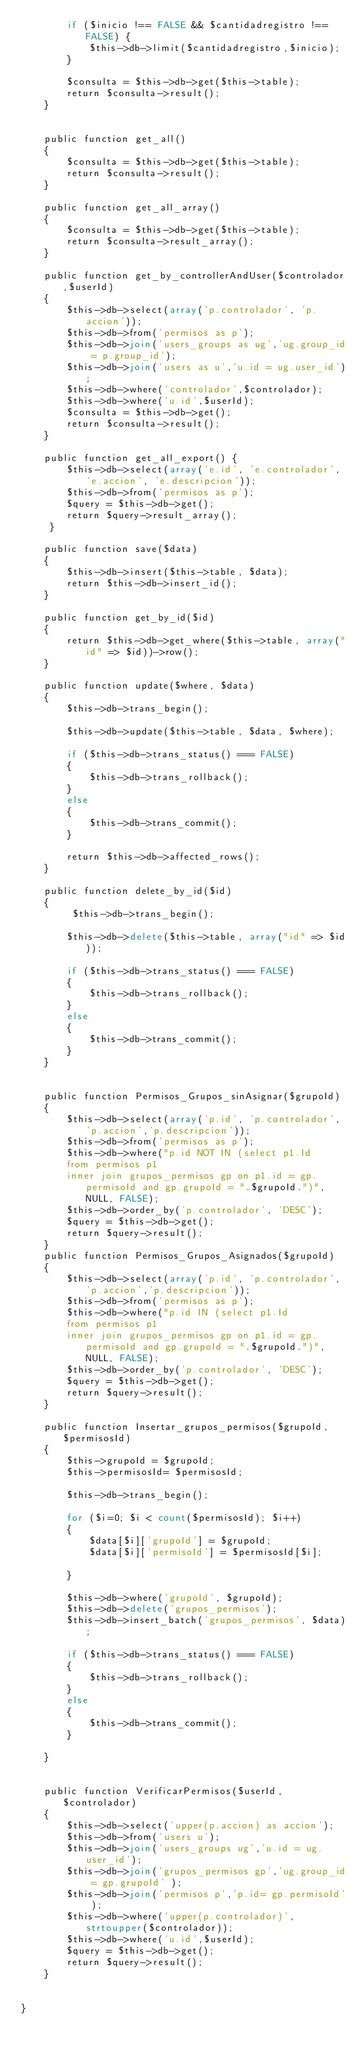Convert code to text. <code><loc_0><loc_0><loc_500><loc_500><_PHP_>		if ($inicio !== FALSE && $cantidadregistro !== FALSE) {
			$this->db->limit($cantidadregistro,$inicio);
		}

		$consulta = $this->db->get($this->table);
		return $consulta->result();
	}


	public function get_all()
	{
		$consulta = $this->db->get($this->table);
		return $consulta->result();
	}

	public function get_all_array()
	{			
		$consulta = $this->db->get($this->table);
		return $consulta->result_array();
	}

	public function get_by_controllerAndUser($controlador,$userId)
	{
		$this->db->select(array('p.controlador', 'p.accion'));
		$this->db->from('permisos as p');
		$this->db->join('users_groups as ug','ug.group_id = p.group_id');
		$this->db->join('users as u','u.id = ug.user_id');
		$this->db->where('controlador',$controlador);
		$this->db->where('u.id',$userId);
		$consulta = $this->db->get();
		return $consulta->result();
	}

	public function get_all_export() {
		$this->db->select(array('e.id', 'e.controlador', 'e.accion', 'e.descripcion'));
		$this->db->from('permisos as p');			
		$query = $this->db->get();
		return $query->result_array();
	 }

	public function save($data)
	{
		$this->db->insert($this->table, $data);
		return $this->db->insert_id();
	}

	public function get_by_id($id)
	{
		return $this->db->get_where($this->table, array("id" => $id))->row();
	}

	public function update($where, $data)
	{
		$this->db->trans_begin();

		$this->db->update($this->table, $data, $where);

		if ($this->db->trans_status() === FALSE)
		{
			$this->db->trans_rollback();
		}
		else
		{
			$this->db->trans_commit();
		}

		return $this->db->affected_rows();
	}

	public function delete_by_id($id)
	{
		 $this->db->trans_begin();
		 
	 	$this->db->delete($this->table, array("id" => $id));

		if ($this->db->trans_status() === FALSE)
		{
			$this->db->trans_rollback();
		}
		else
		{
			$this->db->trans_commit();
		}
	}


	public function Permisos_Grupos_sinAsignar($grupoId)
	{
		$this->db->select(array('p.id', 'p.controlador', 'p.accion','p.descripcion'));
		$this->db->from('permisos as p');
		$this->db->where("p.id NOT IN (select p1.Id 
		from permisos p1
		inner join grupos_permisos gp on p1.id = gp.permisoId and gp.grupoId = ".$grupoId.")", NULL, FALSE);
		$this->db->order_by('p.controlador', 'DESC');
		$query = $this->db->get();
		return $query->result();
	}
	public function Permisos_Grupos_Asignados($grupoId)
	{
		$this->db->select(array('p.id', 'p.controlador', 'p.accion','p.descripcion'));
		$this->db->from('permisos as p');
		$this->db->where("p.id IN (select p1.Id 
		from permisos p1
		inner join grupos_permisos gp on p1.id = gp.permisoId and gp.grupoId = ".$grupoId.")", NULL, FALSE);
		$this->db->order_by('p.controlador', 'DESC');
		$query = $this->db->get();
		return $query->result();
	}

	public function Insertar_grupos_permisos($grupoId,$permisosId)
	{
		$this->grupoId = $grupoId;
		$this->permisosId= $permisosId;

		$this->db->trans_begin();

		for ($i=0; $i < count($permisosId); $i++) 
		{   			
			$data[$i]['grupoId'] = $grupoId;
			$data[$i]['permisoId'] = $permisosId[$i];						
		}

		$this->db->where('grupoId', $grupoId);
		$this->db->delete('grupos_permisos');
		$this->db->insert_batch('grupos_permisos', $data);

		if ($this->db->trans_status() === FALSE)
		{
			$this->db->trans_rollback();
		}
		else
		{
			$this->db->trans_commit();		
		}

	}	
	
	
	public function VerificarPermisos($userId,$controlador)
	{
		$this->db->select('upper(p.accion) as accion');
		$this->db->from('users u');
		$this->db->join('users_groups ug','u.id = ug.user_id');
		$this->db->join('grupos_permisos gp','ug.group_id = gp.grupoId' );
		$this->db->join('permisos p','p.id= gp.permisoId' );
		$this->db->where('upper(p.controlador)',strtoupper($controlador));
		$this->db->where('u.id',$userId);		
		$query = $this->db->get();
		return $query->result();
	}


}
</code> 